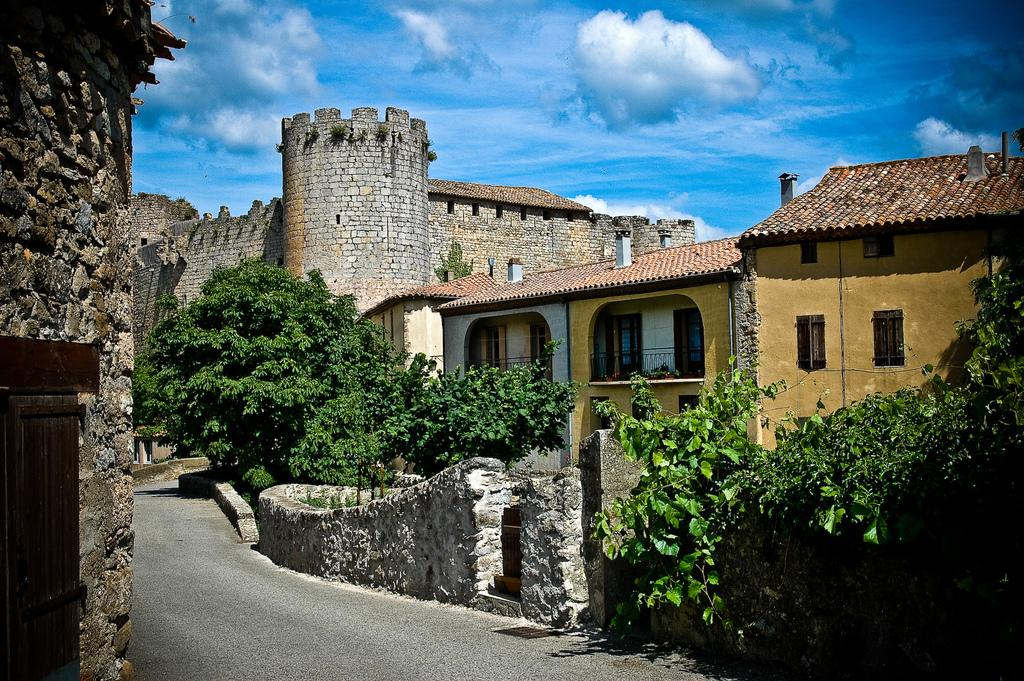What type of structure is the main subject of the image? There is a fort in the image. Are there any other structures nearby? Yes, there is a building beside the fort. What separates the fort and the building? There is a road between the fort and the building. What can be seen around the road? There are trees around the road. Can you tell me how many lawyers are visible in the image? There are no lawyers present in the image. What type of creature has fangs and can be seen in the image? There are no creatures with fangs visible in the image. 